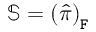<formula> <loc_0><loc_0><loc_500><loc_500>\mathbb { S } = \left ( \hat { \pi } \right ) _ { F }</formula> 